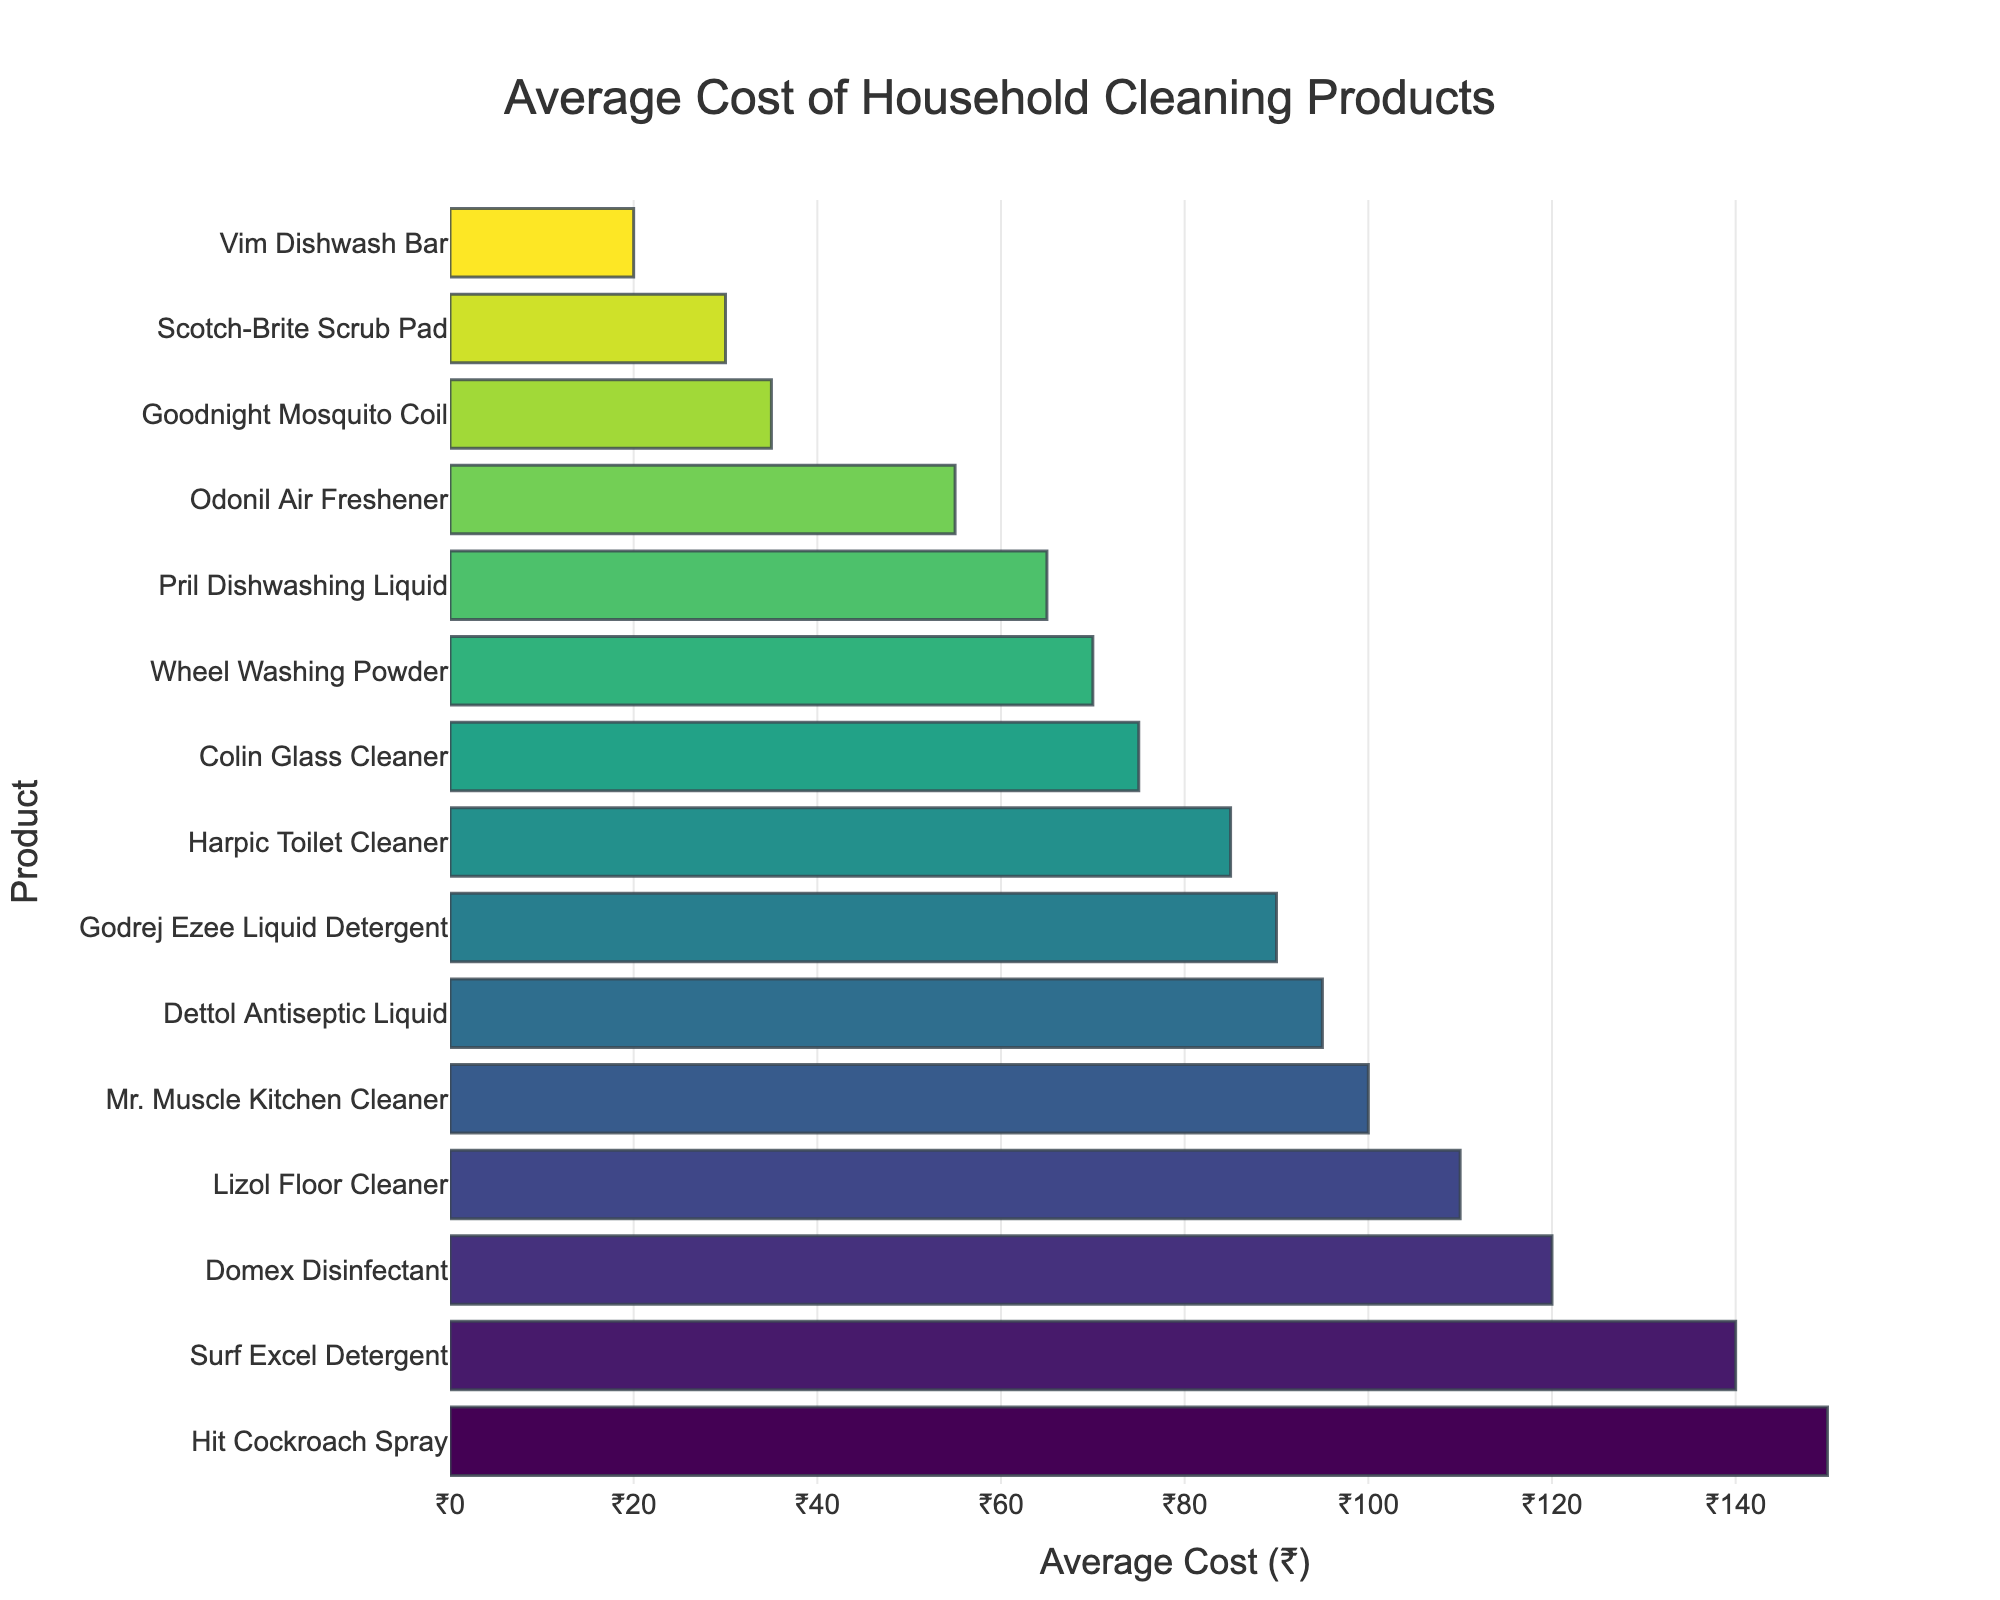Which product has the highest average cost? Look for the bar representing the highest value on the horizontal axis. "Hit Cockroach Spray" has the highest average cost of ₹150.
Answer: Hit Cockroach Spray What is the difference in average cost between Dettol Antiseptic Liquid and Domex Disinfectant? Find the average costs of both products: Dettol Antiseptic Liquid (₹95) and Domex Disinfectant (₹120). Calculate the difference: 120 - 95 = 25.
Answer: ₹25 Which is cheaper: Pril Dishwashing Liquid or Colin Glass Cleaner? Locate the bars for Pril Dishwashing Liquid (₹65) and Colin Glass Cleaner (₹75). Compare their lengths/costs. Pril Dishwashing Liquid is cheaper.
Answer: Pril Dishwashing Liquid What is the combined average cost of Surf Excel Detergent and Vim Dishwash Bar? Get the costs: Surf Excel Detergent (₹140) and Vim Dishwash Bar (₹20). Sum them up: 140 + 20 = 160.
Answer: ₹160 Among Odonil Air Freshener, Mr. Muscle Kitchen Cleaner, and Lizol Floor Cleaner, which product has the lowest average cost? Compare the costs of Odonil Air Freshener (₹55), Mr. Muscle Kitchen Cleaner (₹100), and Lizol Floor Cleaner (₹110). The lowest cost is Odonil Air Freshener.
Answer: Odonil Air Freshener How much more expensive is Hit Cockroach Spray compared to Wheel Washing Powder? Look at the costs for Hit Cockroach Spray (₹150) and Wheel Washing Powder (₹70). Subtract the two values: 150 - 70 = 80.
Answer: ₹80 Which products have an average cost greater than ₹100? Identify the bars that represent costs over 100: Surf Excel Detergent (₹140), Hit Cockroach Spray (₹150), Mr. Muscle Kitchen Cleaner (₹100), Domex Disinfectant (₹120), and Lizol Floor Cleaner (₹110).
Answer: Surf Excel Detergent, Hit Cockroach Spray, Mr. Muscle Kitchen Cleaner, Domex Disinfectant, Lizol Floor Cleaner What is the average cost of the three cheapest products on the list? Identify the three cheapest products: Vim Dishwash Bar (₹20), Scotch-Brite Scrub Pad (₹30), and Goodnight Mosquito Coil (₹35). Calculate their average cost: (20 + 30 + 35) / 3 = 85 / 3 ≈ 28.33.
Answer: ₹28.33 